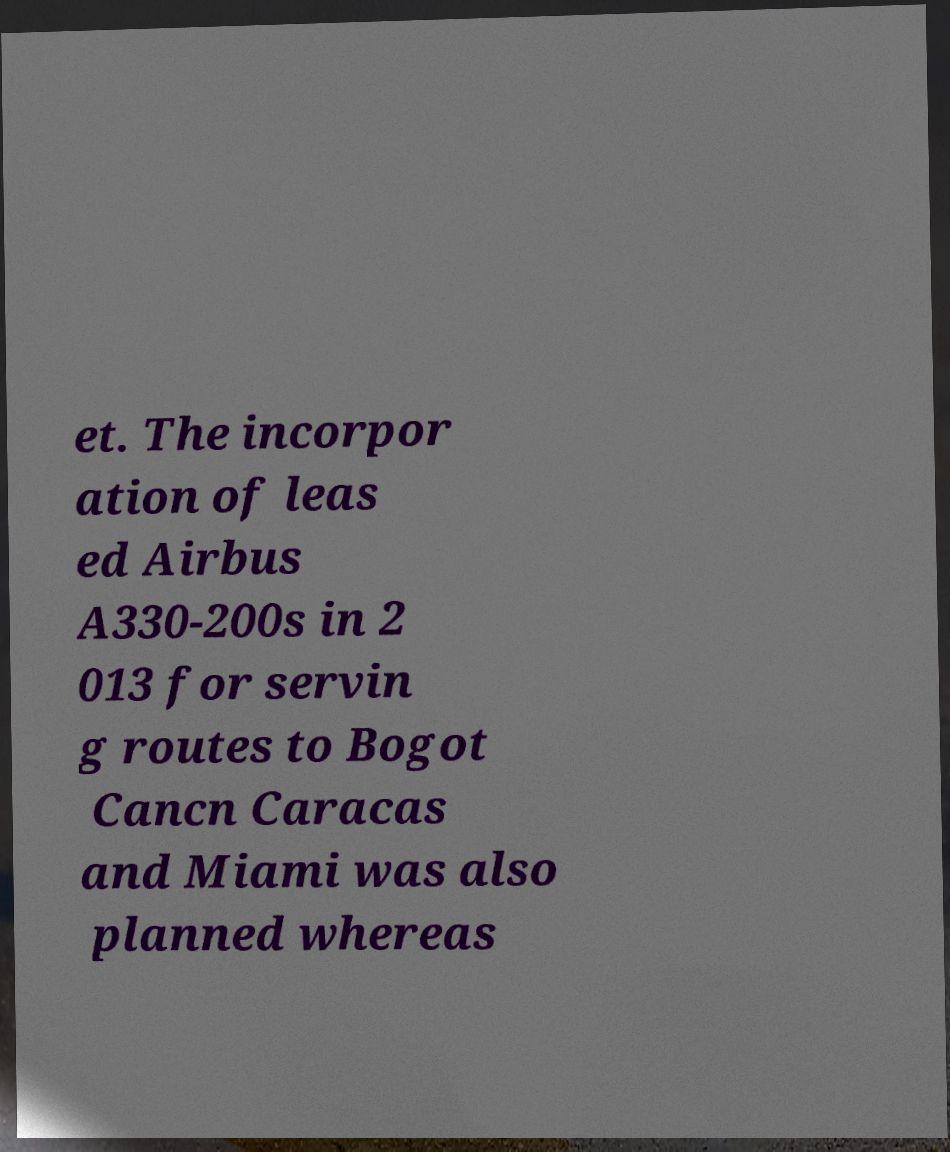There's text embedded in this image that I need extracted. Can you transcribe it verbatim? et. The incorpor ation of leas ed Airbus A330-200s in 2 013 for servin g routes to Bogot Cancn Caracas and Miami was also planned whereas 